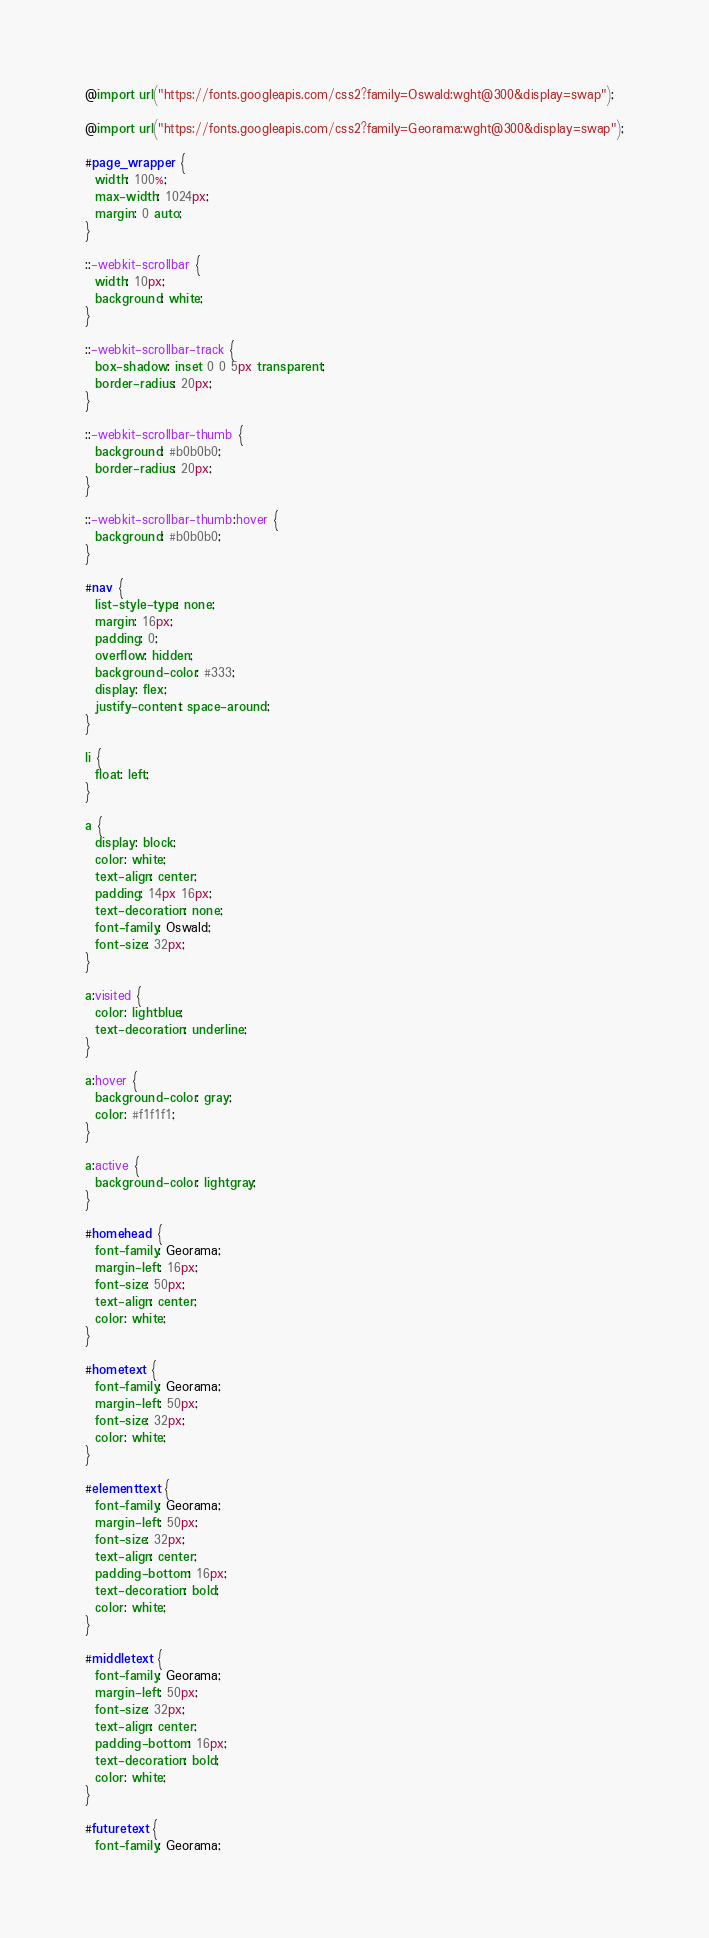Convert code to text. <code><loc_0><loc_0><loc_500><loc_500><_CSS_>@import url("https://fonts.googleapis.com/css2?family=Oswald:wght@300&display=swap");

@import url("https://fonts.googleapis.com/css2?family=Georama:wght@300&display=swap");

#page_wrapper {
  width: 100%;
  max-width: 1024px;
  margin: 0 auto;
}

::-webkit-scrollbar {
  width: 10px;
  background: white;
}

::-webkit-scrollbar-track {
  box-shadow: inset 0 0 5px transparent;
  border-radius: 20px;
}

::-webkit-scrollbar-thumb {
  background: #b0b0b0;
  border-radius: 20px;
}

::-webkit-scrollbar-thumb:hover {
  background: #b0b0b0;
}

#nav {
  list-style-type: none;
  margin: 16px;
  padding: 0;
  overflow: hidden;
  background-color: #333;
  display: flex;
  justify-content: space-around;
}

li {
  float: left;
}

a {
  display: block;
  color: white;
  text-align: center;
  padding: 14px 16px;
  text-decoration: none;
  font-family: Oswald;
  font-size: 32px;
}

a:visited {
  color: lightblue;
  text-decoration: underline;
}

a:hover {
  background-color: gray;
  color: #f1f1f1;
}

a:active {
  background-color: lightgray;
}

#homehead {
  font-family: Georama;
  margin-left: 16px;
  font-size: 50px;
  text-align: center;
  color: white;
}

#hometext {
  font-family: Georama;
  margin-left: 50px;
  font-size: 32px;
  color: white;
}

#elementtext {
  font-family: Georama;
  margin-left: 50px;
  font-size: 32px;
  text-align: center;
  padding-bottom: 16px;
  text-decoration: bold;
  color: white;
}

#middletext {
  font-family: Georama;
  margin-left: 50px;
  font-size: 32px;
  text-align: center;
  padding-bottom: 16px;
  text-decoration: bold;
  color: white;
}

#futuretext {
  font-family: Georama;</code> 